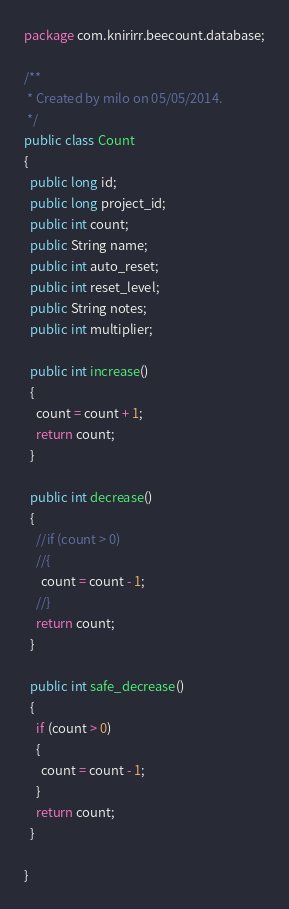Convert code to text. <code><loc_0><loc_0><loc_500><loc_500><_Java_>package com.knirirr.beecount.database;

/**
 * Created by milo on 05/05/2014.
 */
public class Count
{
  public long id;
  public long project_id;
  public int count;
  public String name;
  public int auto_reset;
  public int reset_level;
  public String notes;
  public int multiplier;

  public int increase()
  {
    count = count + 1;
    return count;
  }

  public int decrease()
  {
    //if (count > 0)
    //{
      count = count - 1;
    //}
    return count;
  }

  public int safe_decrease()
  {
    if (count > 0)
    {
      count = count - 1;
    }
    return count;
  }

}
</code> 